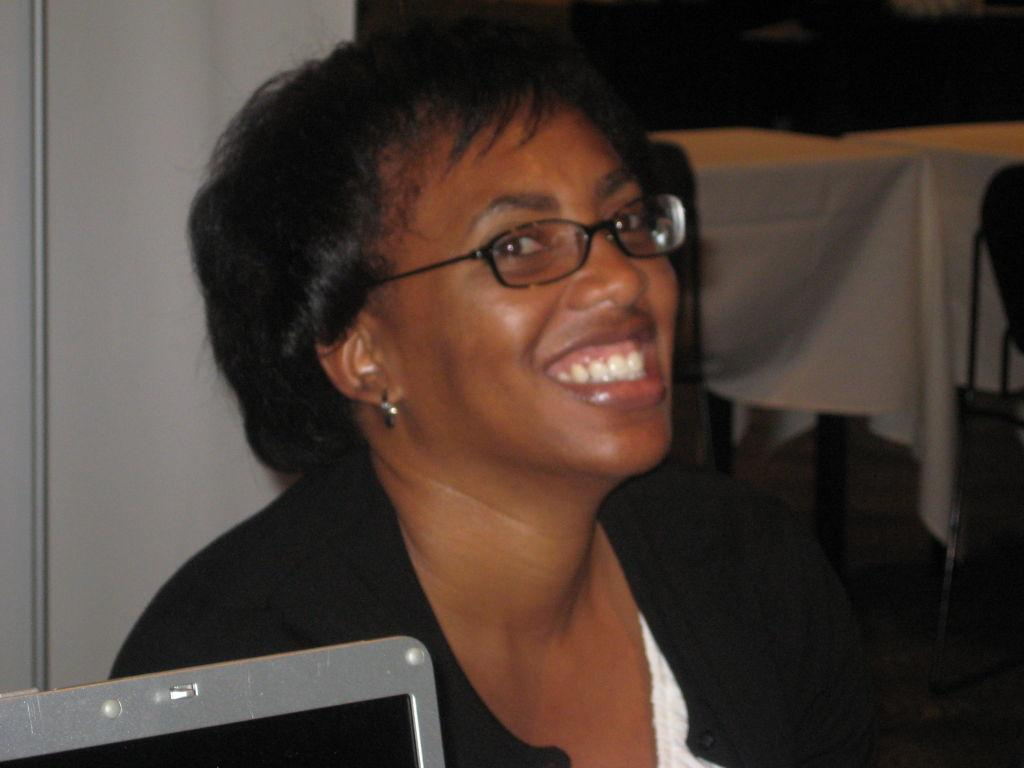Who is present in the image? There is a woman in the image. What is the woman wearing? The woman is wearing a black suit. What can be seen on the left side of the image? There is a laptop on the left side of the image. What is visible in the background of the image? There is a wall in the background of the image. How many ladybugs are crawling on the laptop in the image? There are no ladybugs present in the image; the laptop is not shown with any insects on it. What type of chess pieces can be seen on the table in the image? There is no table or chess pieces visible in the image; it only features a woman, a laptop, and a wall in the background. 